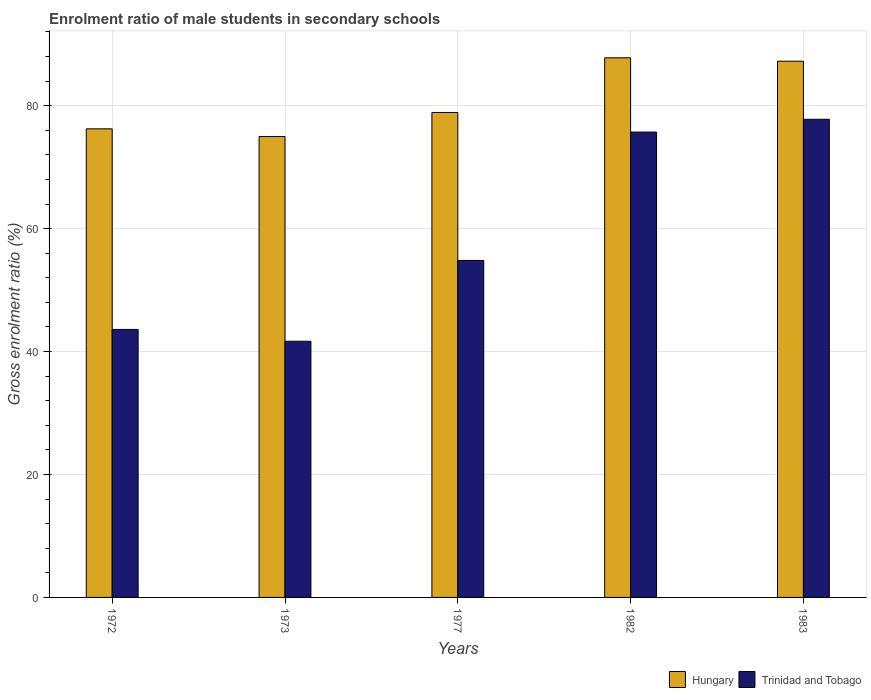Are the number of bars per tick equal to the number of legend labels?
Your answer should be very brief. Yes. How many bars are there on the 2nd tick from the right?
Your answer should be compact. 2. What is the label of the 3rd group of bars from the left?
Offer a terse response. 1977. What is the enrolment ratio of male students in secondary schools in Hungary in 1973?
Offer a very short reply. 74.98. Across all years, what is the maximum enrolment ratio of male students in secondary schools in Hungary?
Offer a terse response. 87.78. Across all years, what is the minimum enrolment ratio of male students in secondary schools in Trinidad and Tobago?
Provide a succinct answer. 41.67. In which year was the enrolment ratio of male students in secondary schools in Hungary minimum?
Provide a short and direct response. 1973. What is the total enrolment ratio of male students in secondary schools in Hungary in the graph?
Your response must be concise. 405.11. What is the difference between the enrolment ratio of male students in secondary schools in Trinidad and Tobago in 1972 and that in 1973?
Your response must be concise. 1.92. What is the difference between the enrolment ratio of male students in secondary schools in Trinidad and Tobago in 1973 and the enrolment ratio of male students in secondary schools in Hungary in 1983?
Offer a very short reply. -45.56. What is the average enrolment ratio of male students in secondary schools in Hungary per year?
Give a very brief answer. 81.02. In the year 1977, what is the difference between the enrolment ratio of male students in secondary schools in Hungary and enrolment ratio of male students in secondary schools in Trinidad and Tobago?
Your answer should be compact. 24.07. In how many years, is the enrolment ratio of male students in secondary schools in Trinidad and Tobago greater than 56 %?
Your answer should be very brief. 2. What is the ratio of the enrolment ratio of male students in secondary schools in Trinidad and Tobago in 1973 to that in 1982?
Your answer should be very brief. 0.55. Is the difference between the enrolment ratio of male students in secondary schools in Hungary in 1972 and 1973 greater than the difference between the enrolment ratio of male students in secondary schools in Trinidad and Tobago in 1972 and 1973?
Your response must be concise. No. What is the difference between the highest and the second highest enrolment ratio of male students in secondary schools in Trinidad and Tobago?
Ensure brevity in your answer.  2.08. What is the difference between the highest and the lowest enrolment ratio of male students in secondary schools in Trinidad and Tobago?
Your response must be concise. 36.11. In how many years, is the enrolment ratio of male students in secondary schools in Hungary greater than the average enrolment ratio of male students in secondary schools in Hungary taken over all years?
Provide a short and direct response. 2. What does the 1st bar from the left in 1982 represents?
Your answer should be compact. Hungary. What does the 2nd bar from the right in 1972 represents?
Your response must be concise. Hungary. Are all the bars in the graph horizontal?
Your response must be concise. No. How many years are there in the graph?
Make the answer very short. 5. What is the difference between two consecutive major ticks on the Y-axis?
Make the answer very short. 20. Does the graph contain any zero values?
Your answer should be very brief. No. How are the legend labels stacked?
Provide a succinct answer. Horizontal. What is the title of the graph?
Offer a terse response. Enrolment ratio of male students in secondary schools. What is the label or title of the X-axis?
Give a very brief answer. Years. What is the label or title of the Y-axis?
Provide a succinct answer. Gross enrolment ratio (%). What is the Gross enrolment ratio (%) of Hungary in 1972?
Provide a succinct answer. 76.23. What is the Gross enrolment ratio (%) of Trinidad and Tobago in 1972?
Make the answer very short. 43.6. What is the Gross enrolment ratio (%) in Hungary in 1973?
Provide a succinct answer. 74.98. What is the Gross enrolment ratio (%) of Trinidad and Tobago in 1973?
Offer a terse response. 41.67. What is the Gross enrolment ratio (%) in Hungary in 1977?
Provide a succinct answer. 78.89. What is the Gross enrolment ratio (%) in Trinidad and Tobago in 1977?
Provide a succinct answer. 54.82. What is the Gross enrolment ratio (%) of Hungary in 1982?
Provide a short and direct response. 87.78. What is the Gross enrolment ratio (%) in Trinidad and Tobago in 1982?
Your response must be concise. 75.7. What is the Gross enrolment ratio (%) in Hungary in 1983?
Your response must be concise. 87.23. What is the Gross enrolment ratio (%) of Trinidad and Tobago in 1983?
Provide a short and direct response. 77.78. Across all years, what is the maximum Gross enrolment ratio (%) in Hungary?
Make the answer very short. 87.78. Across all years, what is the maximum Gross enrolment ratio (%) of Trinidad and Tobago?
Your response must be concise. 77.78. Across all years, what is the minimum Gross enrolment ratio (%) of Hungary?
Give a very brief answer. 74.98. Across all years, what is the minimum Gross enrolment ratio (%) of Trinidad and Tobago?
Your answer should be very brief. 41.67. What is the total Gross enrolment ratio (%) of Hungary in the graph?
Your response must be concise. 405.11. What is the total Gross enrolment ratio (%) of Trinidad and Tobago in the graph?
Your response must be concise. 293.58. What is the difference between the Gross enrolment ratio (%) in Hungary in 1972 and that in 1973?
Provide a succinct answer. 1.25. What is the difference between the Gross enrolment ratio (%) in Trinidad and Tobago in 1972 and that in 1973?
Provide a succinct answer. 1.92. What is the difference between the Gross enrolment ratio (%) in Hungary in 1972 and that in 1977?
Your answer should be compact. -2.66. What is the difference between the Gross enrolment ratio (%) of Trinidad and Tobago in 1972 and that in 1977?
Your response must be concise. -11.22. What is the difference between the Gross enrolment ratio (%) in Hungary in 1972 and that in 1982?
Provide a short and direct response. -11.55. What is the difference between the Gross enrolment ratio (%) of Trinidad and Tobago in 1972 and that in 1982?
Ensure brevity in your answer.  -32.1. What is the difference between the Gross enrolment ratio (%) in Hungary in 1972 and that in 1983?
Give a very brief answer. -11. What is the difference between the Gross enrolment ratio (%) in Trinidad and Tobago in 1972 and that in 1983?
Make the answer very short. -34.19. What is the difference between the Gross enrolment ratio (%) in Hungary in 1973 and that in 1977?
Make the answer very short. -3.91. What is the difference between the Gross enrolment ratio (%) of Trinidad and Tobago in 1973 and that in 1977?
Your answer should be compact. -13.15. What is the difference between the Gross enrolment ratio (%) in Hungary in 1973 and that in 1982?
Your answer should be compact. -12.81. What is the difference between the Gross enrolment ratio (%) of Trinidad and Tobago in 1973 and that in 1982?
Offer a very short reply. -34.03. What is the difference between the Gross enrolment ratio (%) in Hungary in 1973 and that in 1983?
Your answer should be very brief. -12.25. What is the difference between the Gross enrolment ratio (%) of Trinidad and Tobago in 1973 and that in 1983?
Offer a terse response. -36.11. What is the difference between the Gross enrolment ratio (%) in Hungary in 1977 and that in 1982?
Offer a very short reply. -8.89. What is the difference between the Gross enrolment ratio (%) of Trinidad and Tobago in 1977 and that in 1982?
Make the answer very short. -20.88. What is the difference between the Gross enrolment ratio (%) in Hungary in 1977 and that in 1983?
Your answer should be very brief. -8.34. What is the difference between the Gross enrolment ratio (%) of Trinidad and Tobago in 1977 and that in 1983?
Provide a short and direct response. -22.96. What is the difference between the Gross enrolment ratio (%) in Hungary in 1982 and that in 1983?
Keep it short and to the point. 0.55. What is the difference between the Gross enrolment ratio (%) in Trinidad and Tobago in 1982 and that in 1983?
Your answer should be very brief. -2.08. What is the difference between the Gross enrolment ratio (%) in Hungary in 1972 and the Gross enrolment ratio (%) in Trinidad and Tobago in 1973?
Keep it short and to the point. 34.56. What is the difference between the Gross enrolment ratio (%) of Hungary in 1972 and the Gross enrolment ratio (%) of Trinidad and Tobago in 1977?
Your response must be concise. 21.41. What is the difference between the Gross enrolment ratio (%) in Hungary in 1972 and the Gross enrolment ratio (%) in Trinidad and Tobago in 1982?
Offer a terse response. 0.53. What is the difference between the Gross enrolment ratio (%) of Hungary in 1972 and the Gross enrolment ratio (%) of Trinidad and Tobago in 1983?
Your answer should be compact. -1.55. What is the difference between the Gross enrolment ratio (%) of Hungary in 1973 and the Gross enrolment ratio (%) of Trinidad and Tobago in 1977?
Your response must be concise. 20.15. What is the difference between the Gross enrolment ratio (%) of Hungary in 1973 and the Gross enrolment ratio (%) of Trinidad and Tobago in 1982?
Provide a short and direct response. -0.73. What is the difference between the Gross enrolment ratio (%) in Hungary in 1973 and the Gross enrolment ratio (%) in Trinidad and Tobago in 1983?
Give a very brief answer. -2.81. What is the difference between the Gross enrolment ratio (%) of Hungary in 1977 and the Gross enrolment ratio (%) of Trinidad and Tobago in 1982?
Offer a terse response. 3.19. What is the difference between the Gross enrolment ratio (%) in Hungary in 1977 and the Gross enrolment ratio (%) in Trinidad and Tobago in 1983?
Offer a very short reply. 1.11. What is the difference between the Gross enrolment ratio (%) in Hungary in 1982 and the Gross enrolment ratio (%) in Trinidad and Tobago in 1983?
Provide a succinct answer. 10. What is the average Gross enrolment ratio (%) of Hungary per year?
Your answer should be compact. 81.02. What is the average Gross enrolment ratio (%) of Trinidad and Tobago per year?
Provide a short and direct response. 58.72. In the year 1972, what is the difference between the Gross enrolment ratio (%) of Hungary and Gross enrolment ratio (%) of Trinidad and Tobago?
Make the answer very short. 32.63. In the year 1973, what is the difference between the Gross enrolment ratio (%) in Hungary and Gross enrolment ratio (%) in Trinidad and Tobago?
Your response must be concise. 33.3. In the year 1977, what is the difference between the Gross enrolment ratio (%) in Hungary and Gross enrolment ratio (%) in Trinidad and Tobago?
Your answer should be compact. 24.07. In the year 1982, what is the difference between the Gross enrolment ratio (%) in Hungary and Gross enrolment ratio (%) in Trinidad and Tobago?
Keep it short and to the point. 12.08. In the year 1983, what is the difference between the Gross enrolment ratio (%) in Hungary and Gross enrolment ratio (%) in Trinidad and Tobago?
Provide a succinct answer. 9.45. What is the ratio of the Gross enrolment ratio (%) of Hungary in 1972 to that in 1973?
Offer a very short reply. 1.02. What is the ratio of the Gross enrolment ratio (%) in Trinidad and Tobago in 1972 to that in 1973?
Ensure brevity in your answer.  1.05. What is the ratio of the Gross enrolment ratio (%) in Hungary in 1972 to that in 1977?
Provide a succinct answer. 0.97. What is the ratio of the Gross enrolment ratio (%) of Trinidad and Tobago in 1972 to that in 1977?
Offer a terse response. 0.8. What is the ratio of the Gross enrolment ratio (%) in Hungary in 1972 to that in 1982?
Your response must be concise. 0.87. What is the ratio of the Gross enrolment ratio (%) of Trinidad and Tobago in 1972 to that in 1982?
Offer a terse response. 0.58. What is the ratio of the Gross enrolment ratio (%) of Hungary in 1972 to that in 1983?
Provide a short and direct response. 0.87. What is the ratio of the Gross enrolment ratio (%) of Trinidad and Tobago in 1972 to that in 1983?
Give a very brief answer. 0.56. What is the ratio of the Gross enrolment ratio (%) of Hungary in 1973 to that in 1977?
Your answer should be compact. 0.95. What is the ratio of the Gross enrolment ratio (%) in Trinidad and Tobago in 1973 to that in 1977?
Make the answer very short. 0.76. What is the ratio of the Gross enrolment ratio (%) in Hungary in 1973 to that in 1982?
Ensure brevity in your answer.  0.85. What is the ratio of the Gross enrolment ratio (%) of Trinidad and Tobago in 1973 to that in 1982?
Provide a succinct answer. 0.55. What is the ratio of the Gross enrolment ratio (%) of Hungary in 1973 to that in 1983?
Your response must be concise. 0.86. What is the ratio of the Gross enrolment ratio (%) in Trinidad and Tobago in 1973 to that in 1983?
Keep it short and to the point. 0.54. What is the ratio of the Gross enrolment ratio (%) in Hungary in 1977 to that in 1982?
Your answer should be compact. 0.9. What is the ratio of the Gross enrolment ratio (%) of Trinidad and Tobago in 1977 to that in 1982?
Provide a short and direct response. 0.72. What is the ratio of the Gross enrolment ratio (%) of Hungary in 1977 to that in 1983?
Provide a succinct answer. 0.9. What is the ratio of the Gross enrolment ratio (%) of Trinidad and Tobago in 1977 to that in 1983?
Offer a very short reply. 0.7. What is the ratio of the Gross enrolment ratio (%) in Hungary in 1982 to that in 1983?
Give a very brief answer. 1.01. What is the ratio of the Gross enrolment ratio (%) of Trinidad and Tobago in 1982 to that in 1983?
Offer a terse response. 0.97. What is the difference between the highest and the second highest Gross enrolment ratio (%) in Hungary?
Offer a very short reply. 0.55. What is the difference between the highest and the second highest Gross enrolment ratio (%) of Trinidad and Tobago?
Provide a succinct answer. 2.08. What is the difference between the highest and the lowest Gross enrolment ratio (%) in Hungary?
Make the answer very short. 12.81. What is the difference between the highest and the lowest Gross enrolment ratio (%) in Trinidad and Tobago?
Your response must be concise. 36.11. 